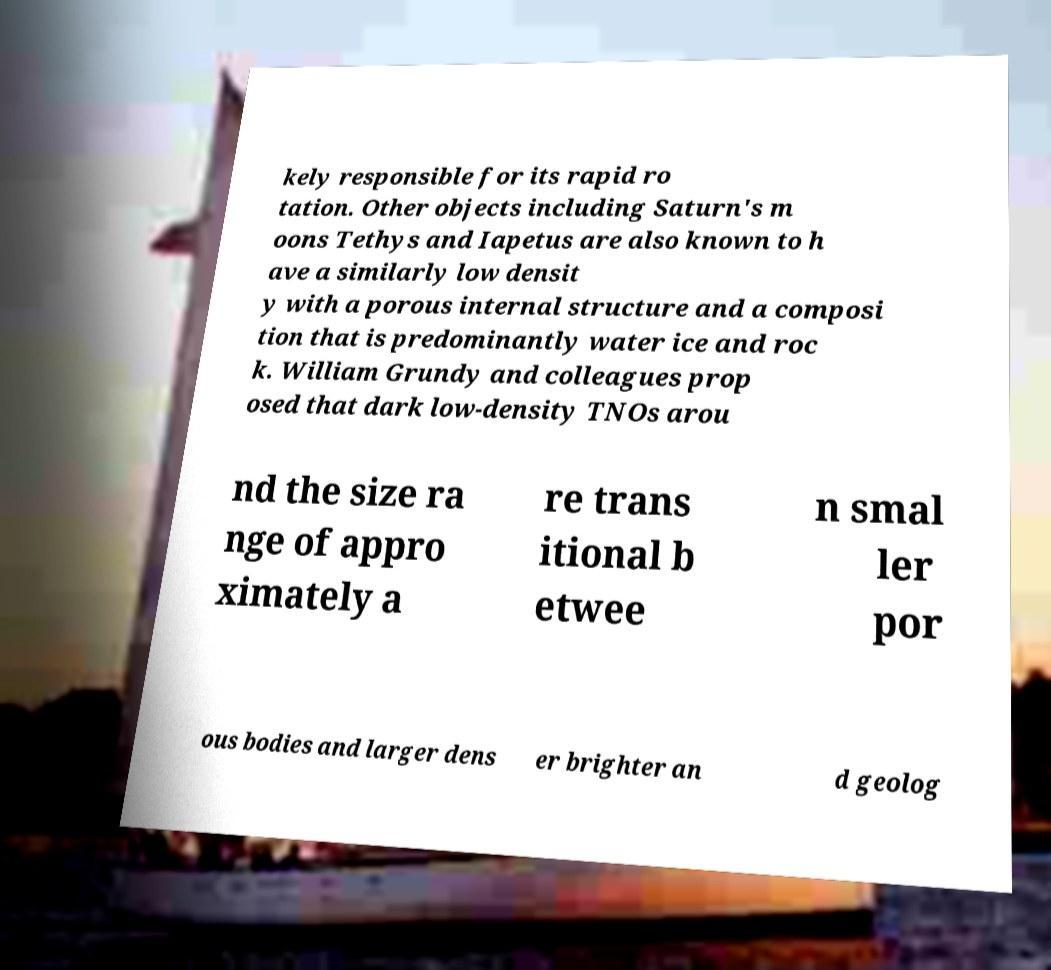Please read and relay the text visible in this image. What does it say? kely responsible for its rapid ro tation. Other objects including Saturn's m oons Tethys and Iapetus are also known to h ave a similarly low densit y with a porous internal structure and a composi tion that is predominantly water ice and roc k. William Grundy and colleagues prop osed that dark low-density TNOs arou nd the size ra nge of appro ximately a re trans itional b etwee n smal ler por ous bodies and larger dens er brighter an d geolog 